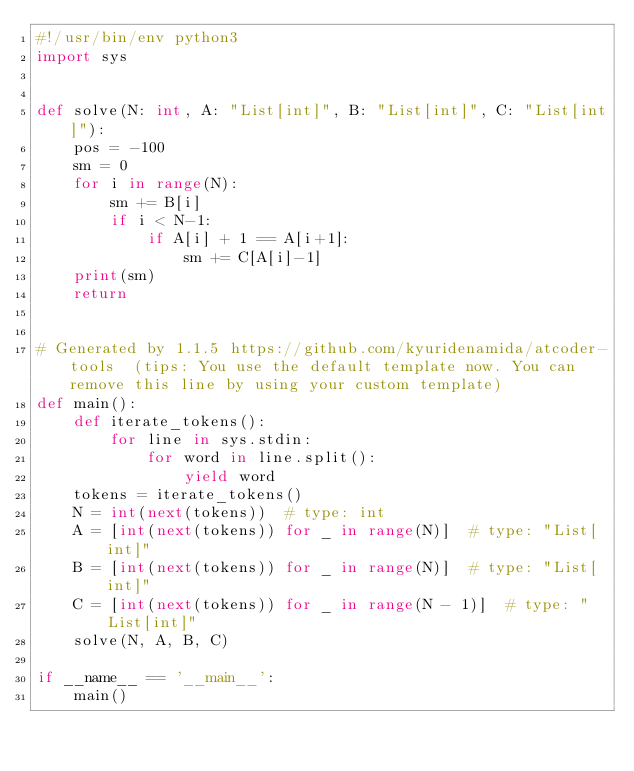Convert code to text. <code><loc_0><loc_0><loc_500><loc_500><_Python_>#!/usr/bin/env python3
import sys


def solve(N: int, A: "List[int]", B: "List[int]", C: "List[int]"):
    pos = -100
    sm = 0 
    for i in range(N):
        sm += B[i]
        if i < N-1:
            if A[i] + 1 == A[i+1]:
                sm += C[A[i]-1]
    print(sm)
    return


# Generated by 1.1.5 https://github.com/kyuridenamida/atcoder-tools  (tips: You use the default template now. You can remove this line by using your custom template)
def main():
    def iterate_tokens():
        for line in sys.stdin:
            for word in line.split():
                yield word
    tokens = iterate_tokens()
    N = int(next(tokens))  # type: int
    A = [int(next(tokens)) for _ in range(N)]  # type: "List[int]"
    B = [int(next(tokens)) for _ in range(N)]  # type: "List[int]"
    C = [int(next(tokens)) for _ in range(N - 1)]  # type: "List[int]"
    solve(N, A, B, C)

if __name__ == '__main__':
    main()
</code> 